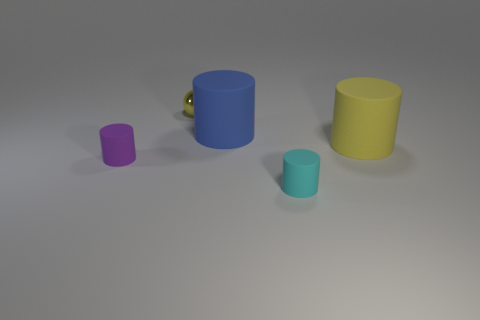Add 2 small red things. How many objects exist? 7 Subtract all spheres. How many objects are left? 4 Subtract 0 green spheres. How many objects are left? 5 Subtract all small balls. Subtract all rubber cylinders. How many objects are left? 0 Add 5 blue rubber objects. How many blue rubber objects are left? 6 Add 2 tiny purple rubber cylinders. How many tiny purple rubber cylinders exist? 3 